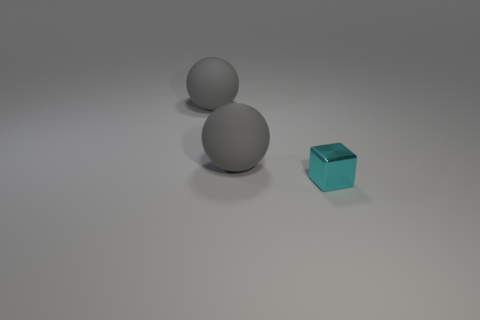Add 2 tiny gray metallic cylinders. How many objects exist? 5 Subtract all cubes. How many objects are left? 2 Subtract all shiny cylinders. Subtract all tiny metal objects. How many objects are left? 2 Add 2 large gray matte balls. How many large gray matte balls are left? 4 Add 2 small blue metallic objects. How many small blue metallic objects exist? 2 Subtract 0 green blocks. How many objects are left? 3 Subtract all gray cubes. Subtract all purple cylinders. How many cubes are left? 1 